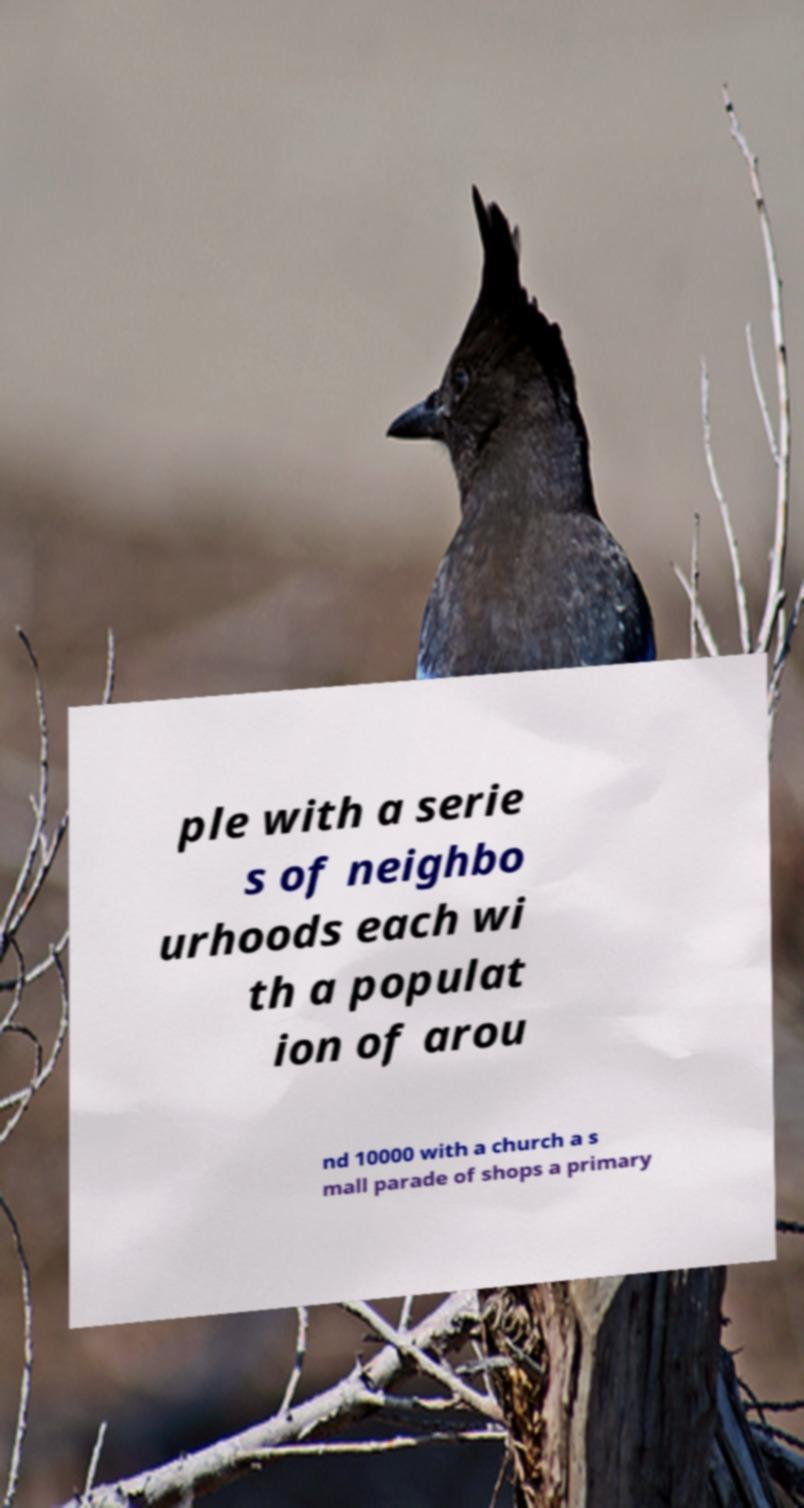For documentation purposes, I need the text within this image transcribed. Could you provide that? ple with a serie s of neighbo urhoods each wi th a populat ion of arou nd 10000 with a church a s mall parade of shops a primary 